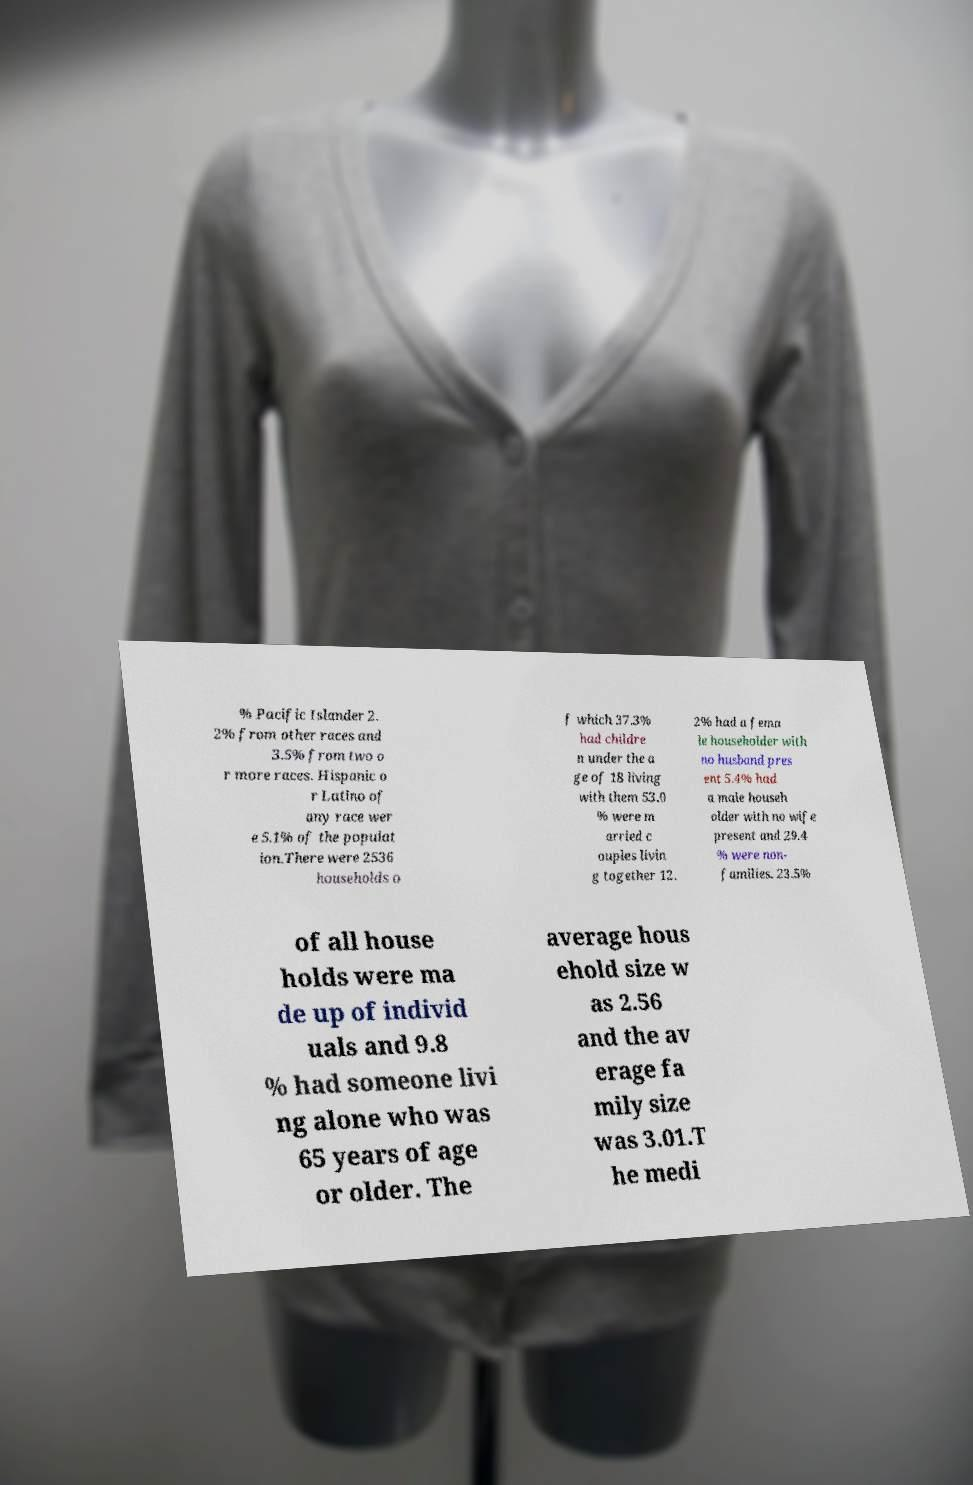Can you read and provide the text displayed in the image?This photo seems to have some interesting text. Can you extract and type it out for me? % Pacific Islander 2. 2% from other races and 3.5% from two o r more races. Hispanic o r Latino of any race wer e 5.1% of the populat ion.There were 2536 households o f which 37.3% had childre n under the a ge of 18 living with them 53.0 % were m arried c ouples livin g together 12. 2% had a fema le householder with no husband pres ent 5.4% had a male househ older with no wife present and 29.4 % were non- families. 23.5% of all house holds were ma de up of individ uals and 9.8 % had someone livi ng alone who was 65 years of age or older. The average hous ehold size w as 2.56 and the av erage fa mily size was 3.01.T he medi 